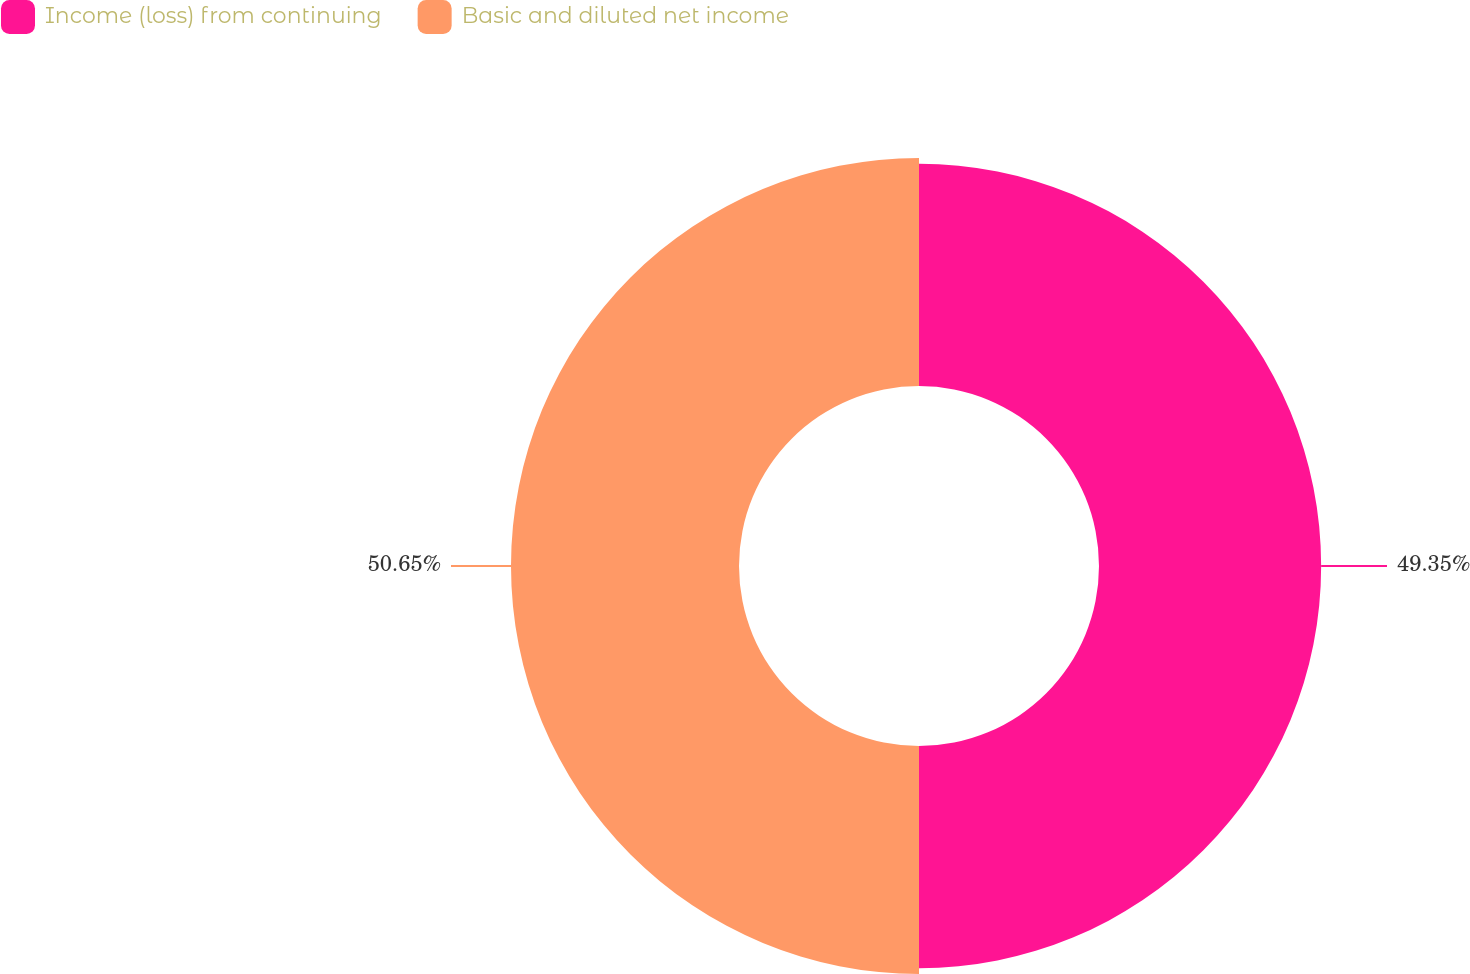Convert chart to OTSL. <chart><loc_0><loc_0><loc_500><loc_500><pie_chart><fcel>Income (loss) from continuing<fcel>Basic and diluted net income<nl><fcel>49.35%<fcel>50.65%<nl></chart> 